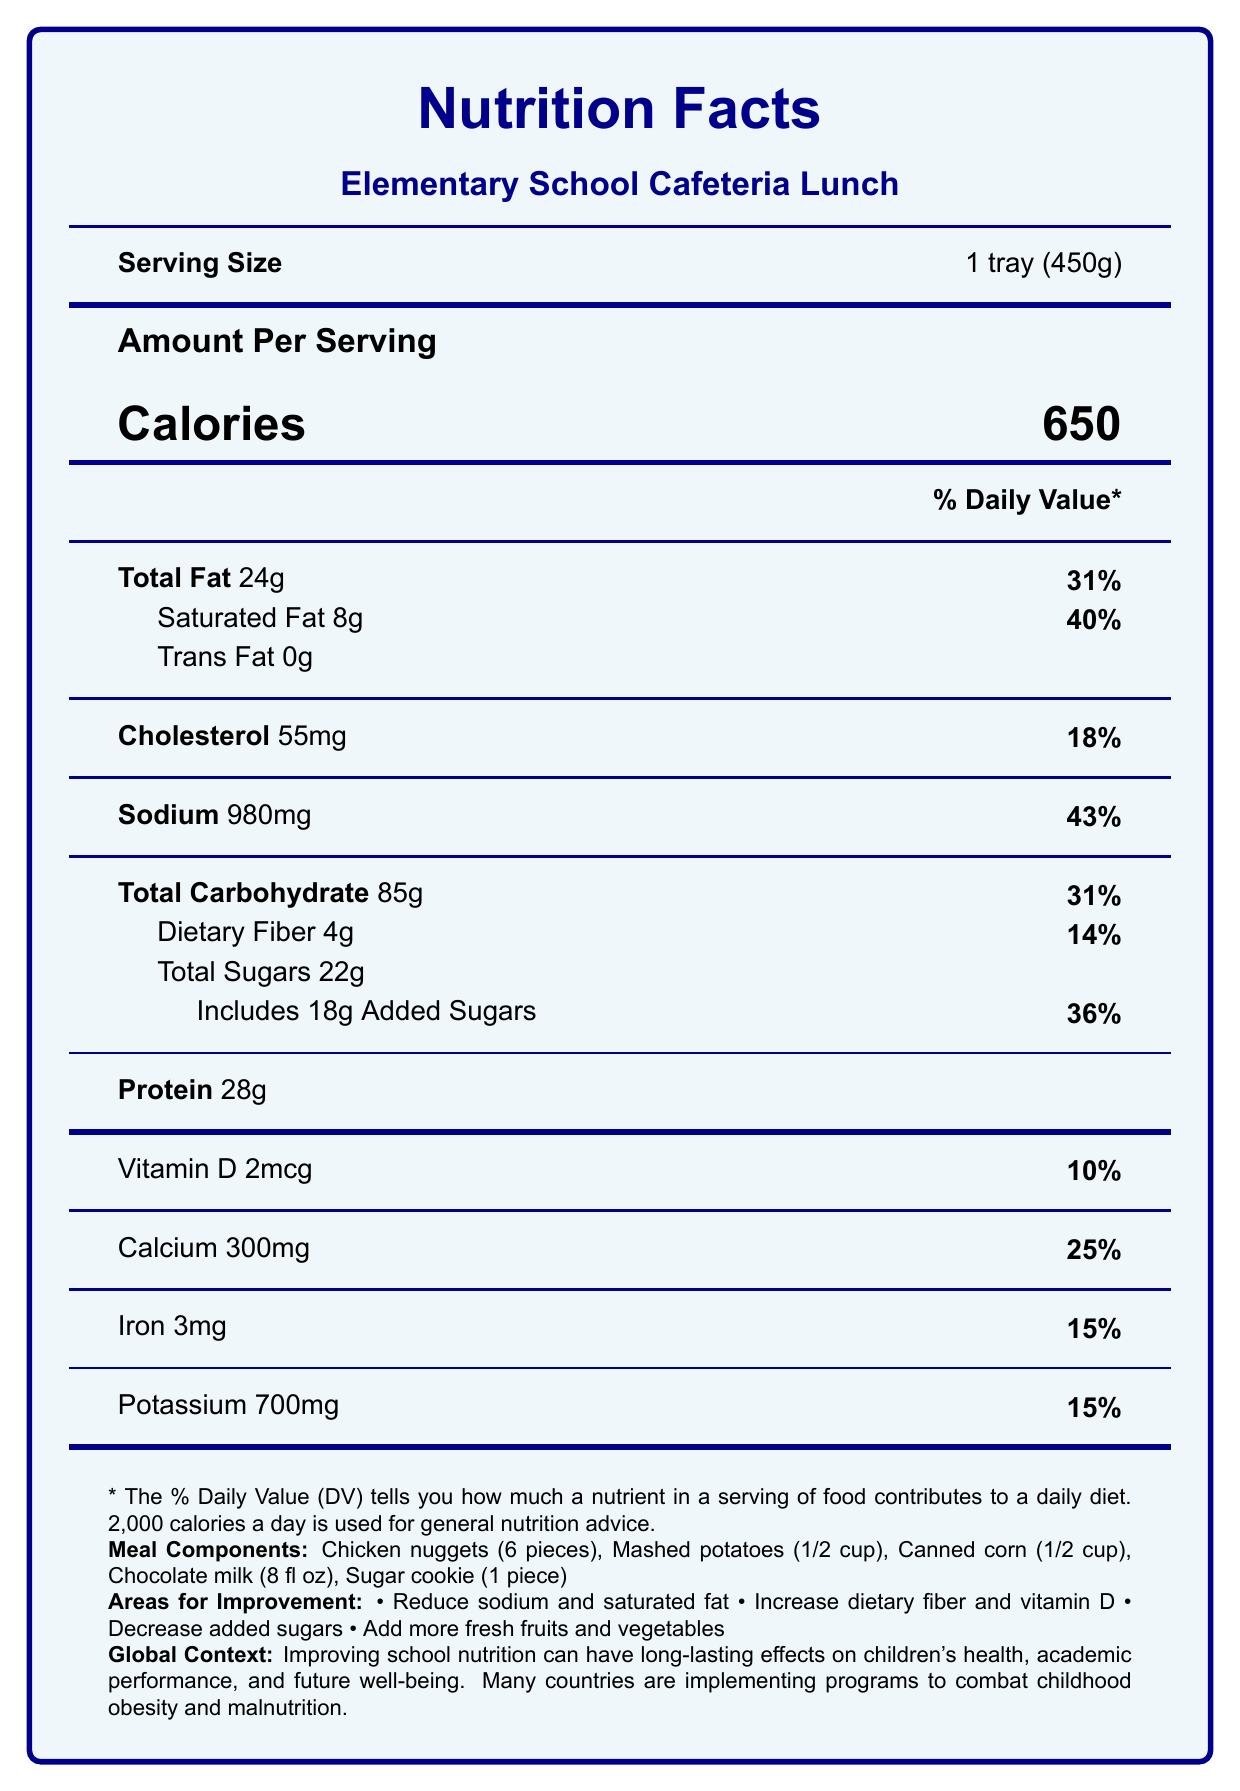what is the serving size? The serving size is mentioned directly below the product name 'Elementary School Cafeteria Lunch' as '1 tray (450g)'.
Answer: 1 tray (450g) how many calories are in one serving? The document lists the calories per serving clearly as 650.
Answer: 650 how much total fat is in this lunch? The total fat content is specified as 24g under 'Total Fat' section.
Answer: 24g what is the percentage of daily value for sodium? The sodium content's daily value percentage is listed next to the amount as 43%.
Answer: 43% how much dietary fiber does the lunch provide? Under the 'Total Carbohydrate' section, dietary fiber amount is mentioned as 4g.
Answer: 4g which component of the meal is likely contributing the most to the added sugars? The document notes that the lunch includes 18g of added sugars, and since chocolate milk and cookies typically contain high added sugars, these are the likely sources.
Answer: Chocolate milk and sugar cookie which of the following is an area for nutritional improvement in the lunch? A. Increase protein B. Reduce sodium C. Eliminate trans fat D. Reduce vitamin D The document lists 'Reduce sodium content by using less processed foods' under areas for improvement.
Answer: B what main dish is included in the lunch? A. Chicken nuggets B. Pizza C. Sandwich D. Hotdog Under the 'Meal Components' section, 'Chicken nuggets (6 pieces)' is listed as the main dish.
Answer: A is the amount of total sugars less than 20g? The document states the total sugars are 22g, which is more than 20g.
Answer: No summarize the document. The document provides a comprehensive breakdown of the nutritional content of a typical school lunch. It highlights potential areas for improvement and provides a global context for the importance of nutritious school meals.
Answer: The document is a Nutrition Facts Label for an Elementary School Cafeteria Lunch, providing details like serving size, calories, and the nutritional content per serving. It highlights areas for nutritional improvement such as reducing sodium and added sugars and includes educational notes on the importance of balanced nutrition for children. Additionally, it contextualizes the global importance of improving school lunches to combat childhood obesity and malnutrition. how many servings per container? The document specifies in the 'Serving Size' section that there is 1 serving per container.
Answer: 1 what is the percentage of daily value for added sugars? Next to the 'Includes 18g Added Sugars' entry, the daily value percentage is listed as 36%.
Answer: 36% does the meal include any fresh fruits? The meal components listed are Chicken nuggets, Mashed potatoes, Canned corn, Chocolate milk, and a Sugar cookie, none of which are fresh fruits.
Answer: No what comparison is made to highlight an international context? The global context section mentions how some countries like Japan and Finland excel in nutritious school lunch programs, adding perspective on how improving school nutrition can benefit children's health worldwide.
Answer: The comparison is made to school lunch programs in countries like Japan and Finland, which are known for their nutritious and balanced meals. how is childhood obesity addressed in the document? In the 'Global Context' section, it states that childhood obesity is a growing issue globally and improving school lunches is one strategy to combat it.
Answer: The document mentions that improving school nutrition can combat childhood obesity, which is a growing concern worldwide. what is the main dish in this lunch? Under the 'Meal Components' section, Chicken nuggets (6 pieces) is listed as the main dish.
Answer: Chicken nuggets (6 pieces) are there any plant-based protein sources listed? The meal components listed include Chicken nuggets, which is an animal-based protein, and no plant-based proteins are mentioned.
Answer: No how does the document suggest to increase dietary fiber? In the 'Areas for Improvement' section, it suggests increasing dietary fiber by incorporating more whole grains and vegetables.
Answer: By adding more whole grains and vegetables. which nutrient's daily value percentage is 40%? The document lists the daily value percentage for saturated fat as 40%.
Answer: Saturated Fat what is the amount of vitamin D supplied per serving? In the nutrient section at the bottom of the document, vitamin D is listed as 2mcg with a 10% daily value.
Answer: 2mcg what is the main idea of the global context section? The global context section emphasizes the importance of nutritious school meals and the efforts globally to combat childhood obesity and improve children's health through better nutrition.
Answer: Improving school nutrition can have long-lasting positive impacts on children's health and various countries are taking steps to address childhood malnutrition. how much calcium does the lunch provide? The document specifies that the lunch provides 300mg of calcium, which is 25% of the daily value.
Answer: 300mg what are the meal components? The meal components are mentioned at the end of the document in the 'Meal Components' section.
Answer: Chicken nuggets (6 pieces), Mashed potatoes (1/2 cup), Canned corn (1/2 cup), Chocolate milk (8 fl oz), Sugar cookie (1 piece) why is reducing saturated fat important? While not explicitly stated, the high saturated fat content (40%) indicates that it's an area needing improvement to lower cardiovascular risk.
Answer: Reducing saturated fat is important for improving overall heart health and reducing the risk of cardiovascular diseases. 